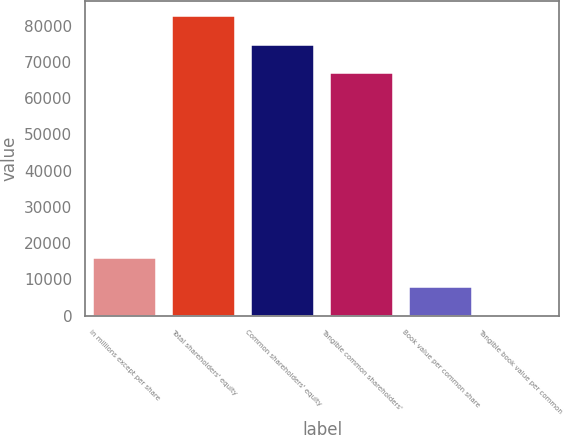<chart> <loc_0><loc_0><loc_500><loc_500><bar_chart><fcel>in millions except per share<fcel>Total shareholders' equity<fcel>Common shareholders' equity<fcel>Tangible common shareholders'<fcel>Book value per common share<fcel>Tangible book value per common<nl><fcel>15807.9<fcel>82555.8<fcel>74723.4<fcel>66891<fcel>7975.5<fcel>143.11<nl></chart> 